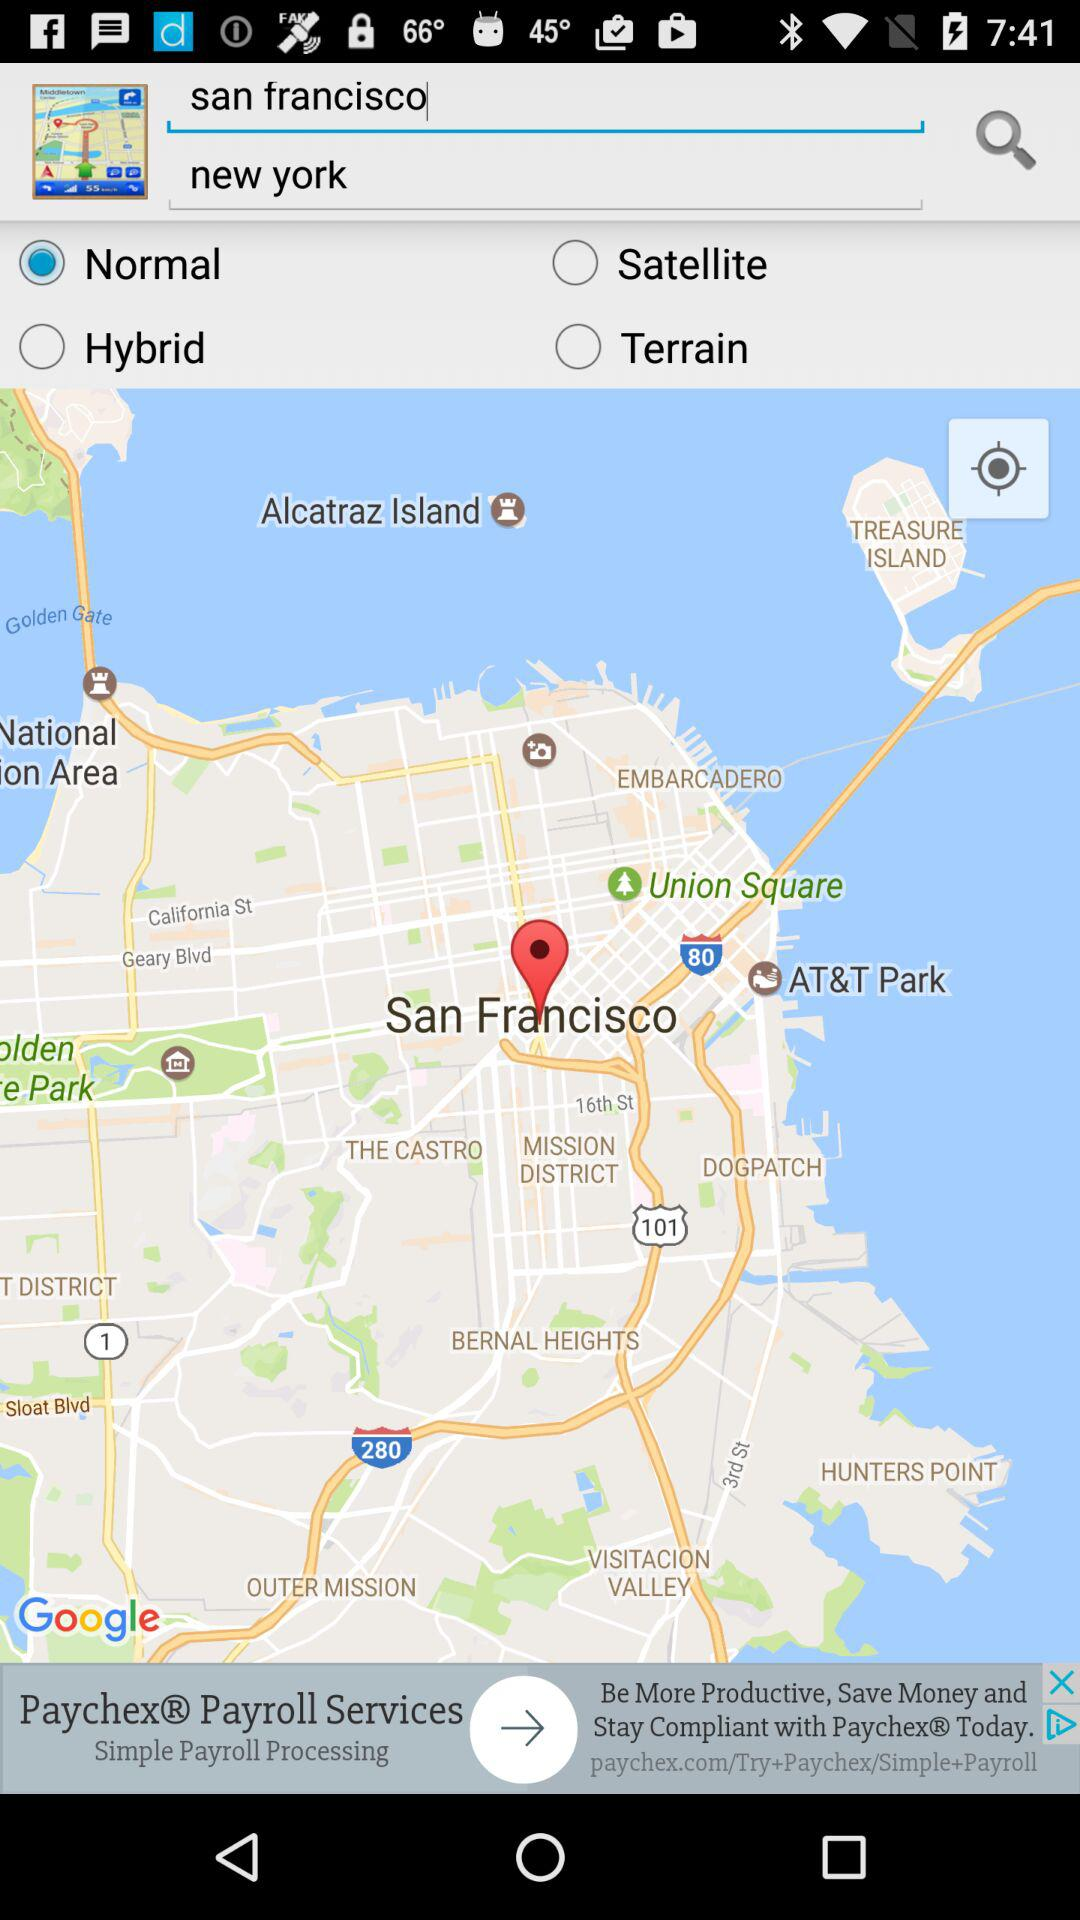Is “Normal” selected or not?
Answer the question using a single word or phrase. "Normal" is selected. 